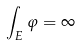Convert formula to latex. <formula><loc_0><loc_0><loc_500><loc_500>\int _ { E } \varphi = \infty</formula> 